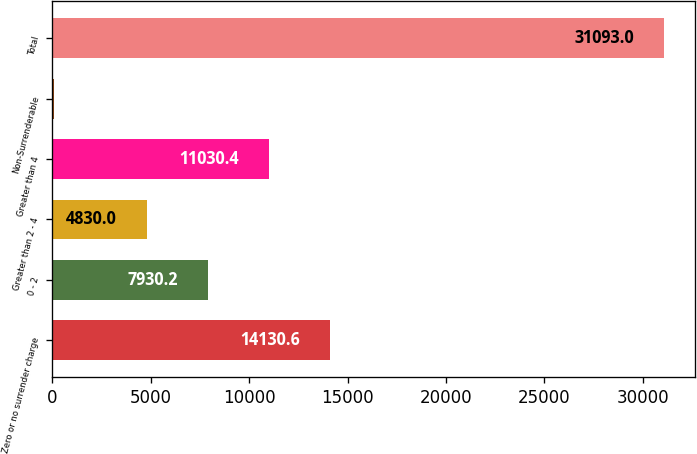Convert chart. <chart><loc_0><loc_0><loc_500><loc_500><bar_chart><fcel>Zero or no surrender charge<fcel>0 - 2<fcel>Greater than 2 - 4<fcel>Greater than 4<fcel>Non-Surrenderable<fcel>Total<nl><fcel>14130.6<fcel>7930.2<fcel>4830<fcel>11030.4<fcel>91<fcel>31093<nl></chart> 